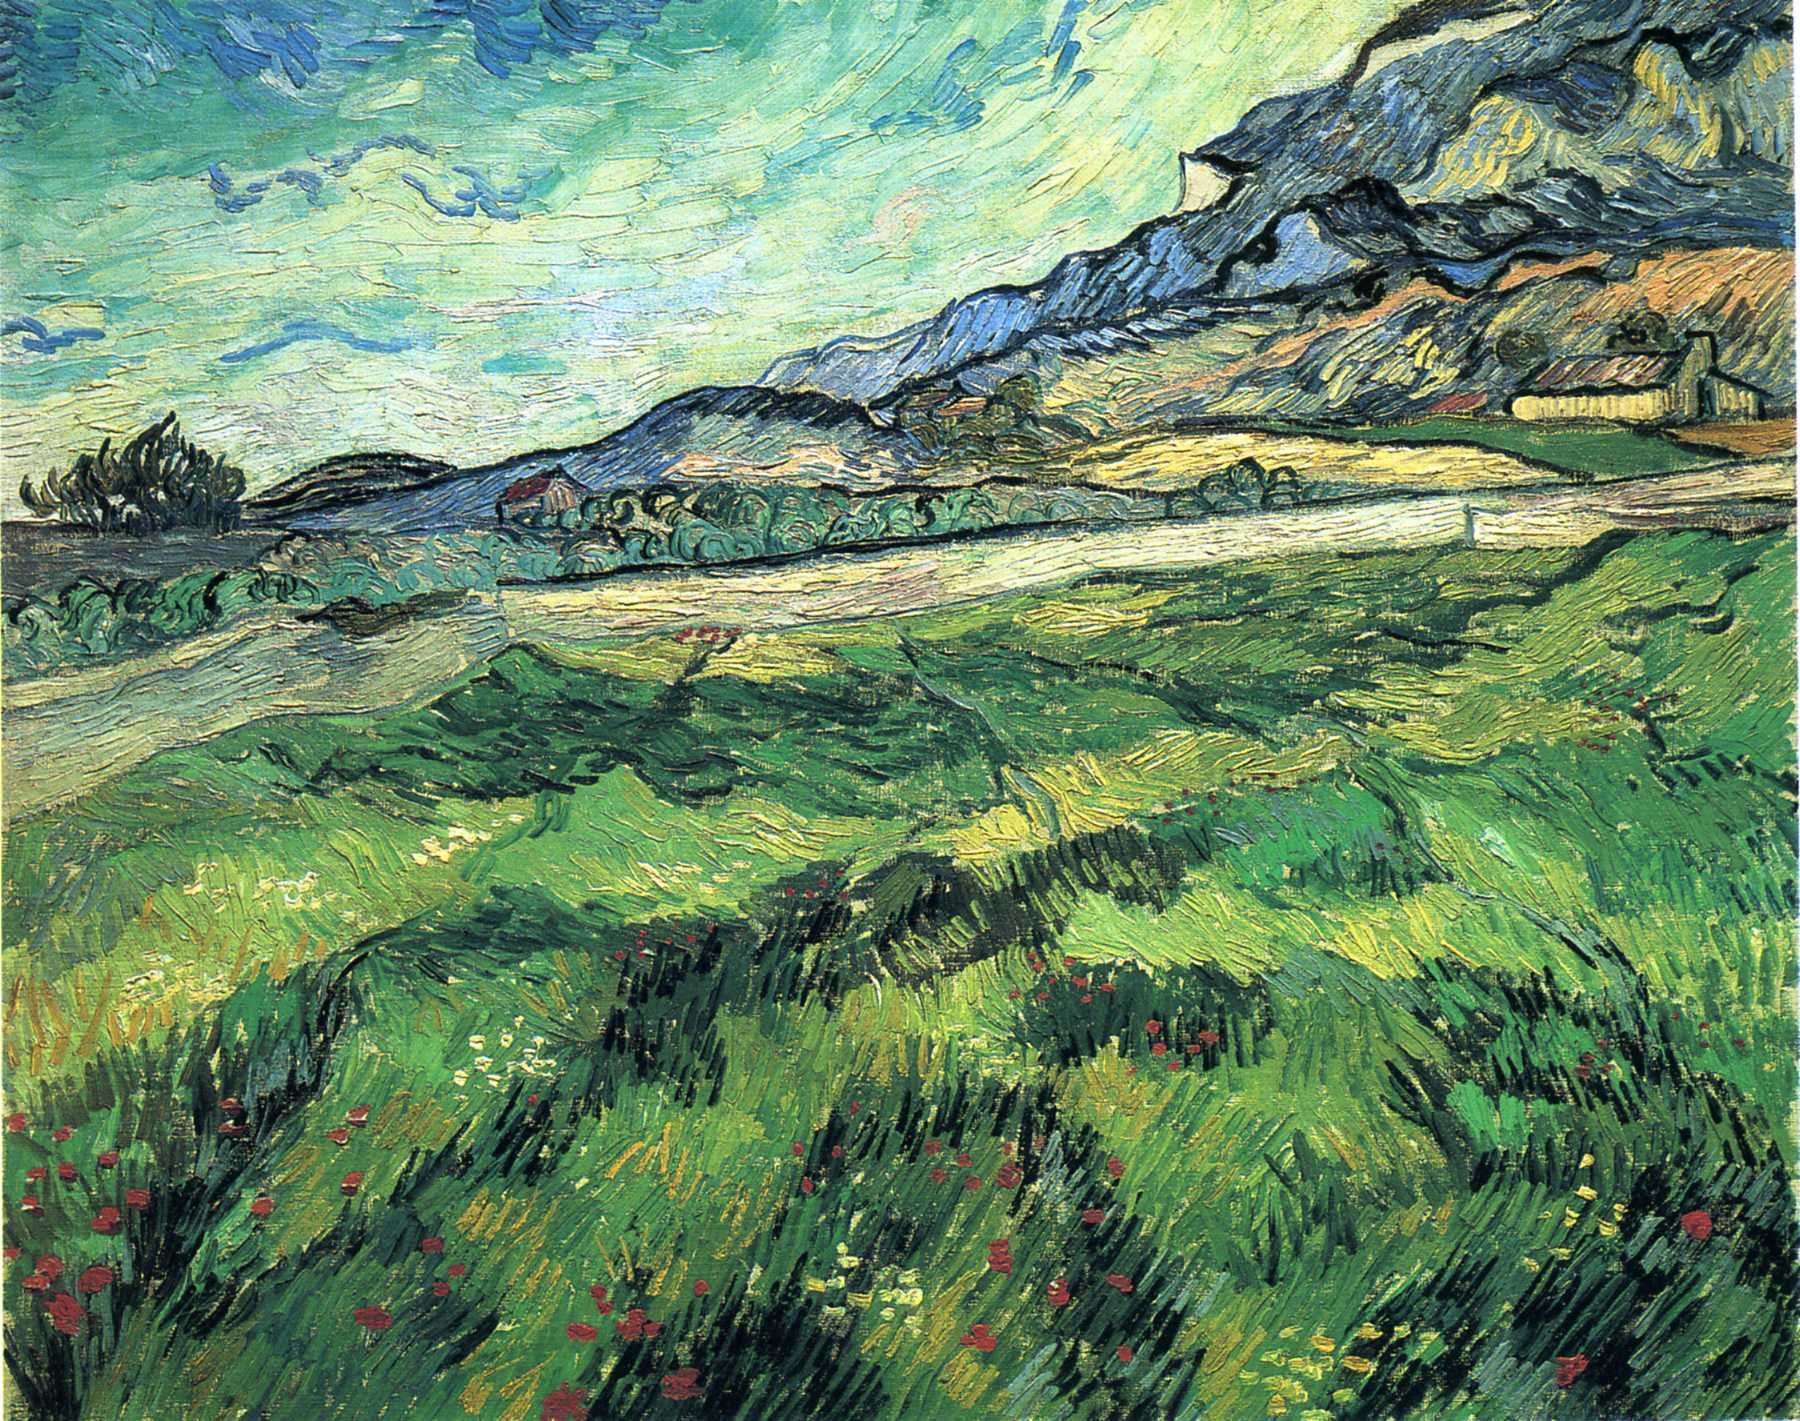Describe the texture and technique used in this painting. Van Gogh's technique in this painting is marked by thick, expressive brushstrokes that add a vibrant texture to the scene. The technique, known as impasto, involves applying paint thickly so that it stands out from the surface, giving a three-dimensional quality to the landscape. The directional strokes create a sense of movement and flow, particularly in the sky and the field. This method brings a tactile quality to the visual experience, making the scenery feel almost tangible. The visible, energetic brushstrokes are a hallmark of Van Gogh's style, capturing his intense emotional engagement with the subject matter. If these fields could talk, what stories would they tell? If these fields could talk, they would recount tales of changing seasons, mornings kissed by the dew, and the rustle of life teeming within the tall grasses and wildflowers. They'd speak of the quiet persistence of nature's beauty and how they stood as silent witnesses to the brooding artist who once captured their essence on canvas. They would tell of soliloquies whispered by the wind, and the timeless journey from seed to bloom, embodying the cycles of life, creation, and wonder. Imagine a scenario where you are walking through this field. What would you experience? As you step into this lush field, a wave of calm envelops you. The wildflowers gently sway in the breeze, their colors vivid and alive under the warm glow of the afternoon sun. The air is filled with the sweet fragrance of blooms mingled with the earthy scent of grass. Above, the sky is a dynamic canvas, the clouds swirling gracefully as if painted by an invisible hand. The distant mountain stands as a silent guardian, its rugged peaks contrasting with the gentle undulations of the field. Every step you take is cushioned by the soft, yielding earth, and the rhythmic symphony of nature – the chirping of birds, the rustle of leaves – creates a harmonious backdrop, making you feel a deep connection with the serene landscape around you. 